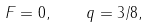<formula> <loc_0><loc_0><loc_500><loc_500>F = 0 , \quad q = 3 / 8 ,</formula> 